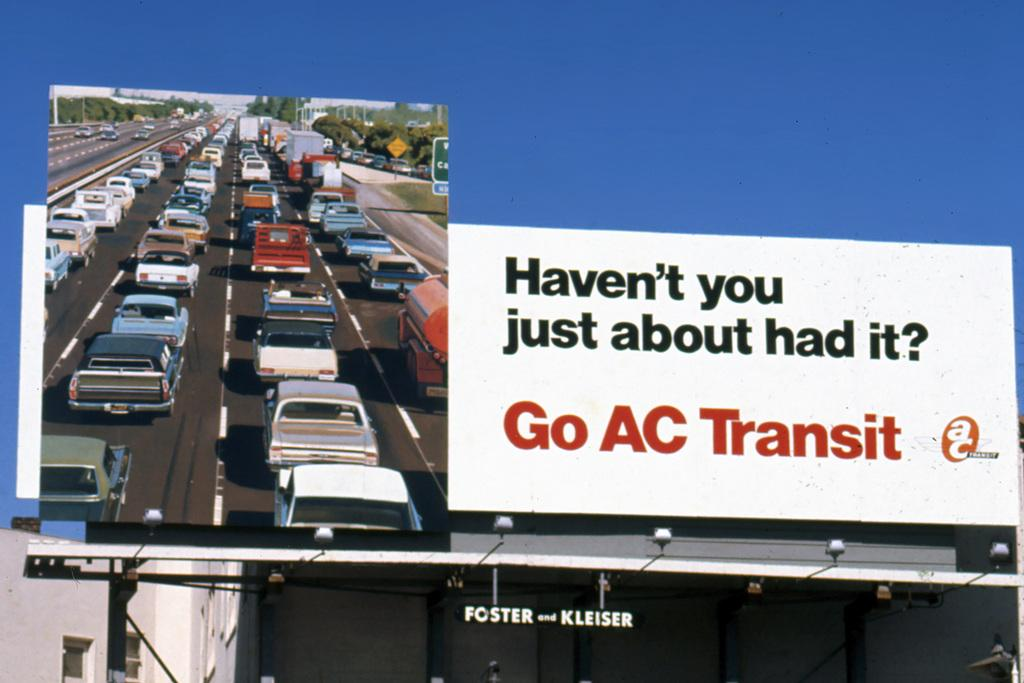<image>
Describe the image concisely. A billboard for AC Transit shows a traffic jam. 